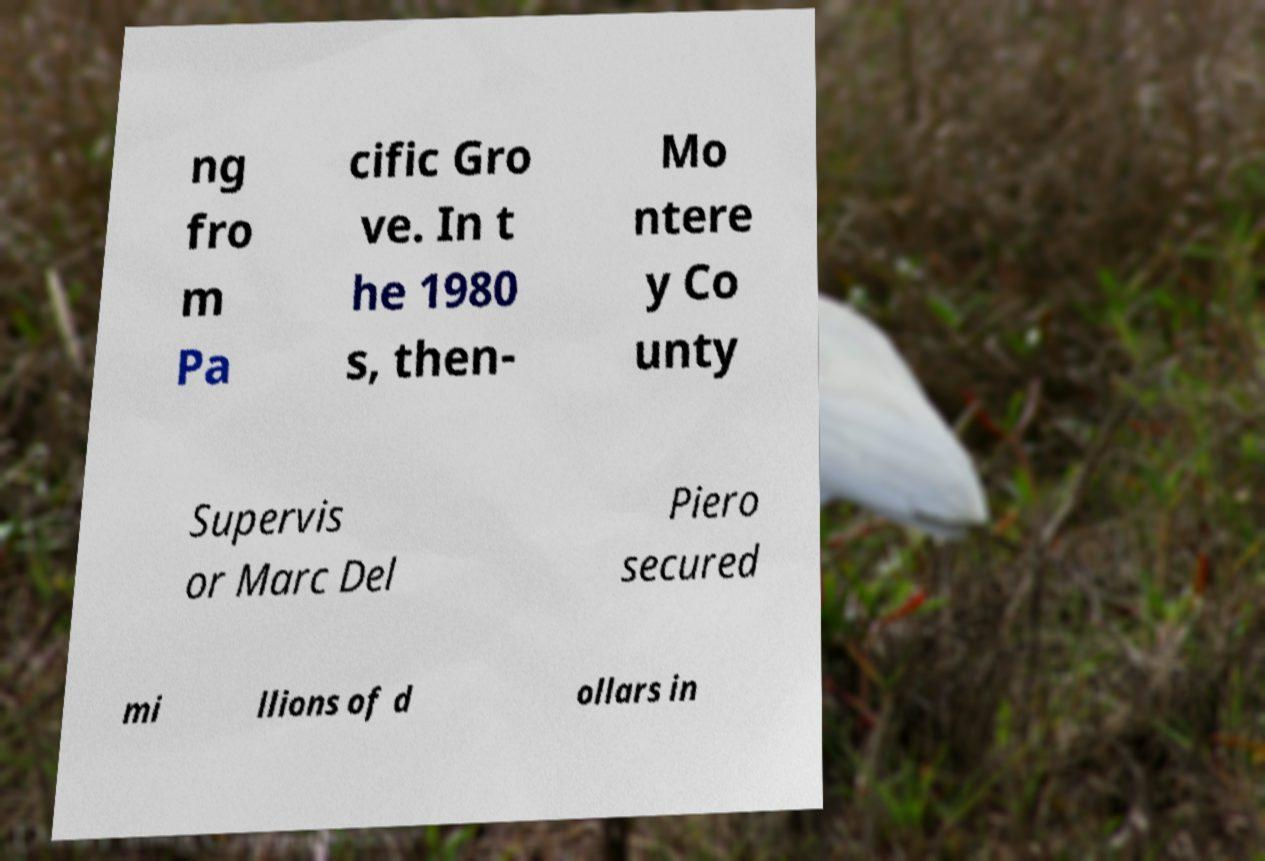Can you accurately transcribe the text from the provided image for me? ng fro m Pa cific Gro ve. In t he 1980 s, then- Mo ntere y Co unty Supervis or Marc Del Piero secured mi llions of d ollars in 